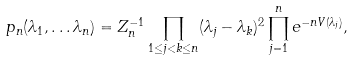<formula> <loc_0><loc_0><loc_500><loc_500>p _ { n } ( \lambda _ { 1 } , \dots \lambda _ { n } ) = Z _ { n } ^ { - 1 } \prod _ { 1 \leq j < k \leq n } ( \lambda _ { j } - \lambda _ { k } ) ^ { 2 } \prod _ { j = 1 } ^ { n } e ^ { - n V ( \lambda _ { j } ) } ,</formula> 